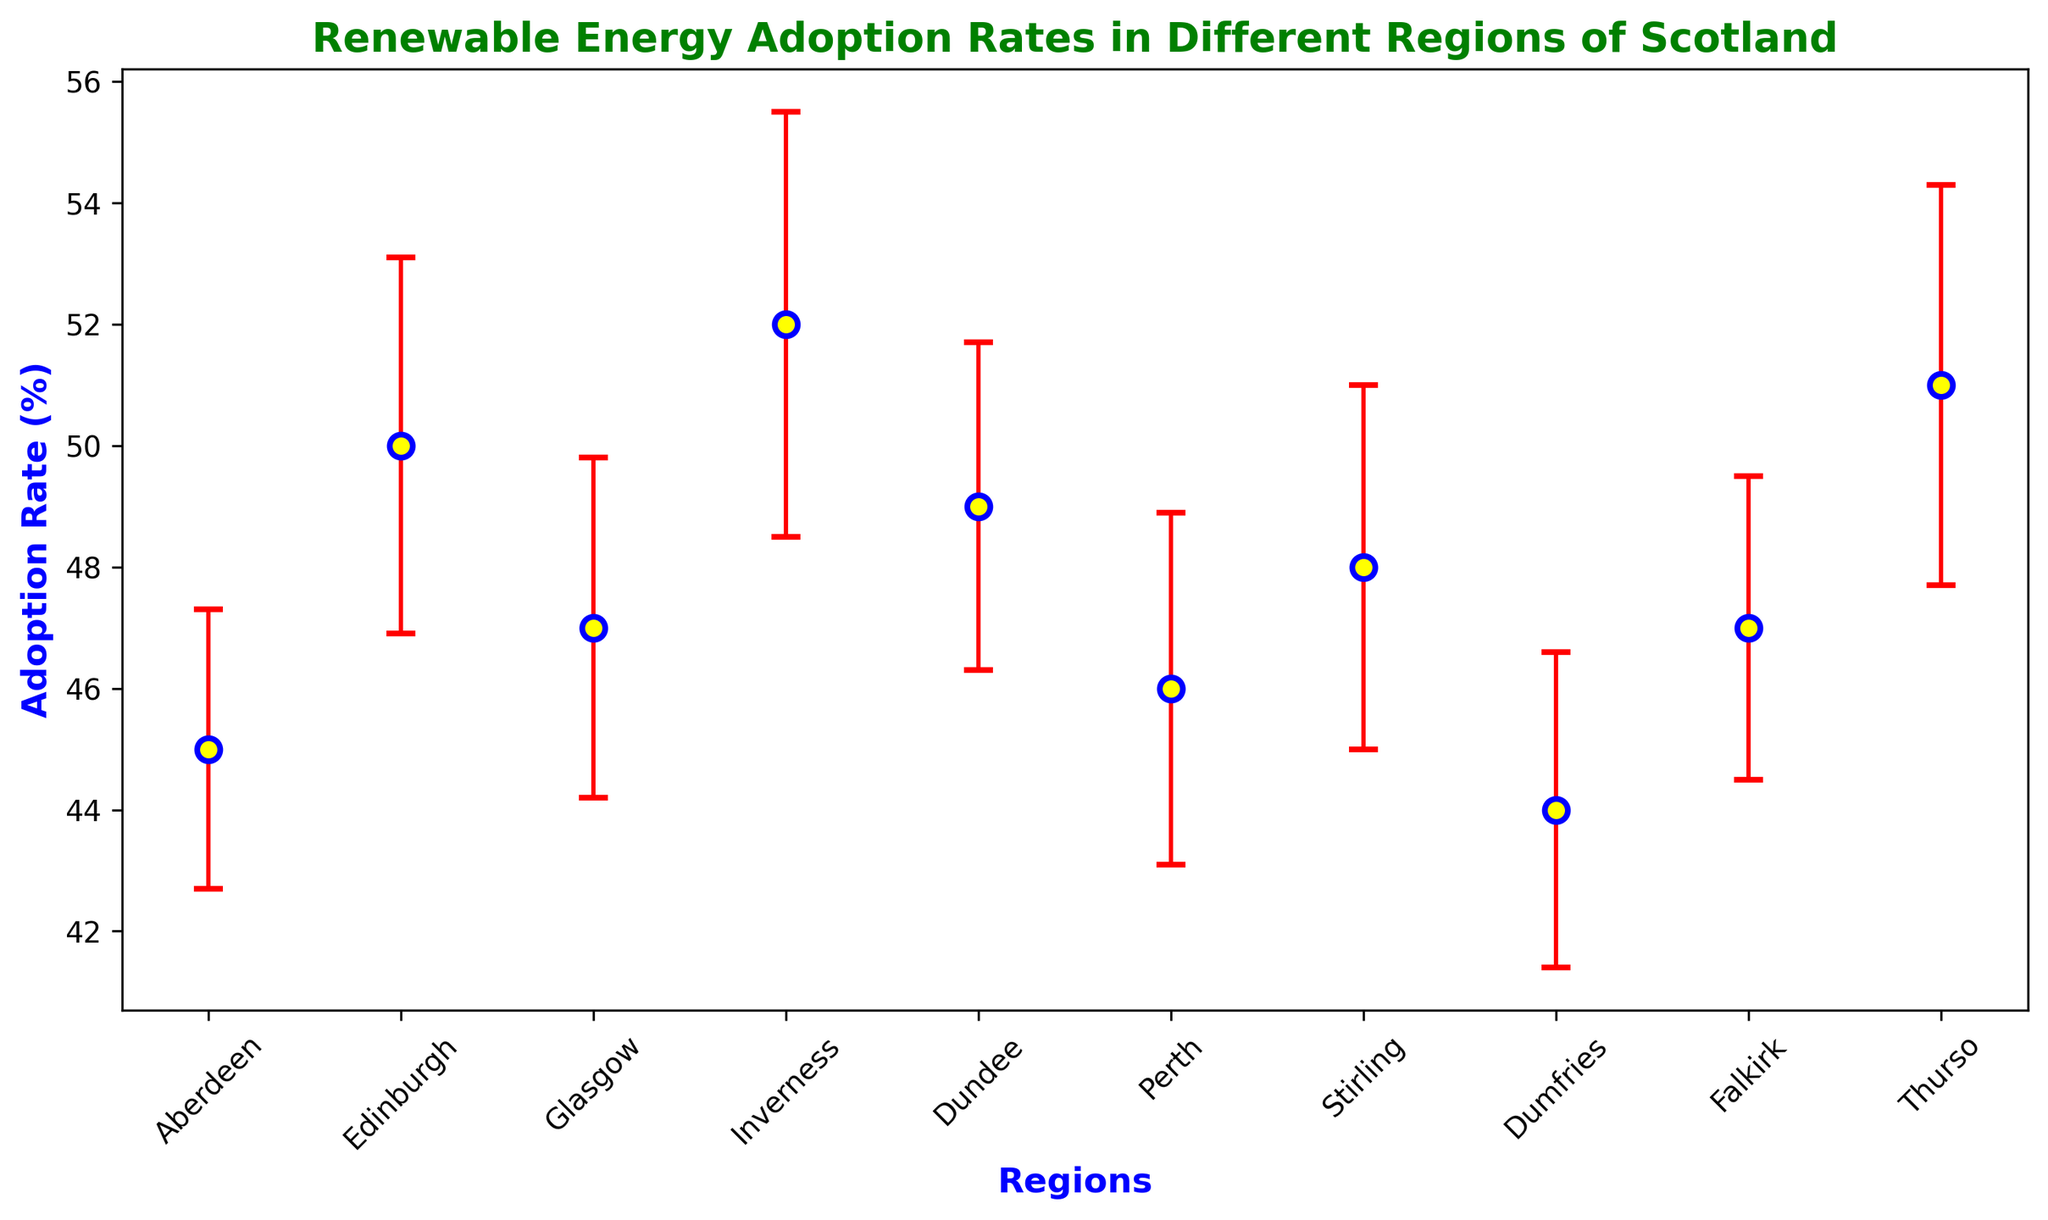What is the region with the highest adoption rate of renewable energy? The highest adoption rate can be identified by looking at the region with the tallest vertical marker.
Answer: Inverness Which regions have adoption rates higher than 50%? By comparing the adoption rates to 50%, we find that Inverness and Thurso have rates higher than 50%.
Answer: Inverness, Thurso What is the mean adoption rate across all regions? Sum all adoption rates (45 + 50 + 47 + 52 + 49 + 46 + 48 + 44 + 47 + 51) = 479 and divide by the number of regions (10). 479/10 = 47.9%
Answer: 47.9% Which region has the smallest standard deviation in adoption rate? The smallest standard deviation can be identified by looking at the region with the shortest error bar.
Answer: Aberdeen What is the difference in adoption rates between Thurso and Dumfries? Subtract Dumfries' adoption rate (44) from Thurso's adoption rate (51). 51 - 44 = 7%
Answer: 7% Is the adoption rate in Edinburgh significantly higher than in Aberdeen? Compare the adoption rates of Edinburgh (50) to Aberdeen (45) and consider their standard deviations (3.1 and 2.3 respectively). 50 is higher than 45.
Answer: Yes Which regions have the same adoption rate? By comparing each adoption rate, we see that Glasgow and Falkirk both have adoption rates of 47%.
Answer: Glasgow, Falkirk What is the range of adoption rates among all regions? Find the difference between the maximum adoption rate (52, Inverness) and the minimum adoption rate (44, Dumfries). 52 - 44 = 8%
Answer: 8% How does Thurso's adoption rate compare to the overall mean adoption rate? Calculate the mean adoption rate (47.9%). Thurso's rate (51%) is higher than the mean rate.
Answer: Higher What is the average standard deviation for the regions? Sum the standard deviations (2.3, 3.1, 2.8, 3.5, 2.7, 2.9, 3.0, 2.6, 2.5, 3.3) = 29.7 and divide by the number of regions (10). 29.7/10 = 2.97%
Answer: 2.97% 